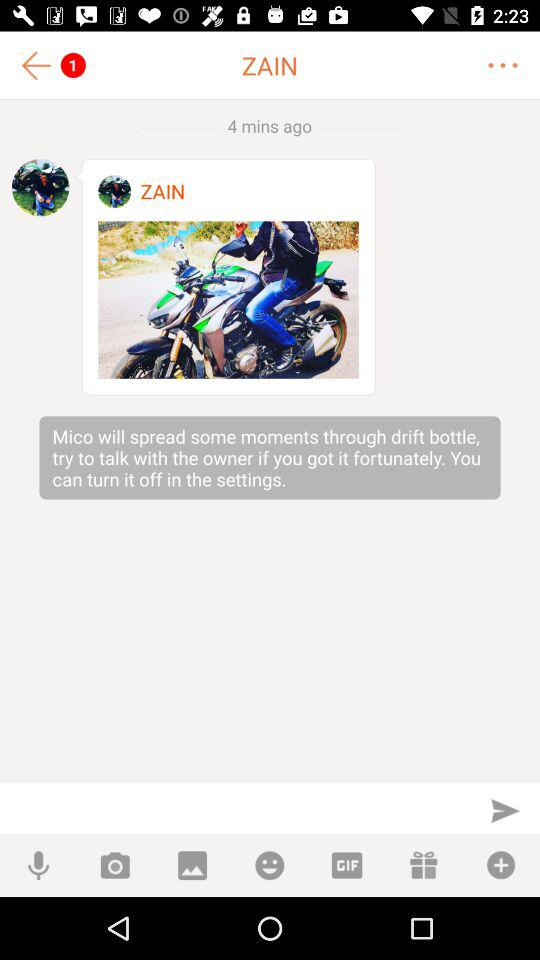When was it last updated?
When the provided information is insufficient, respond with <no answer>. <no answer> 